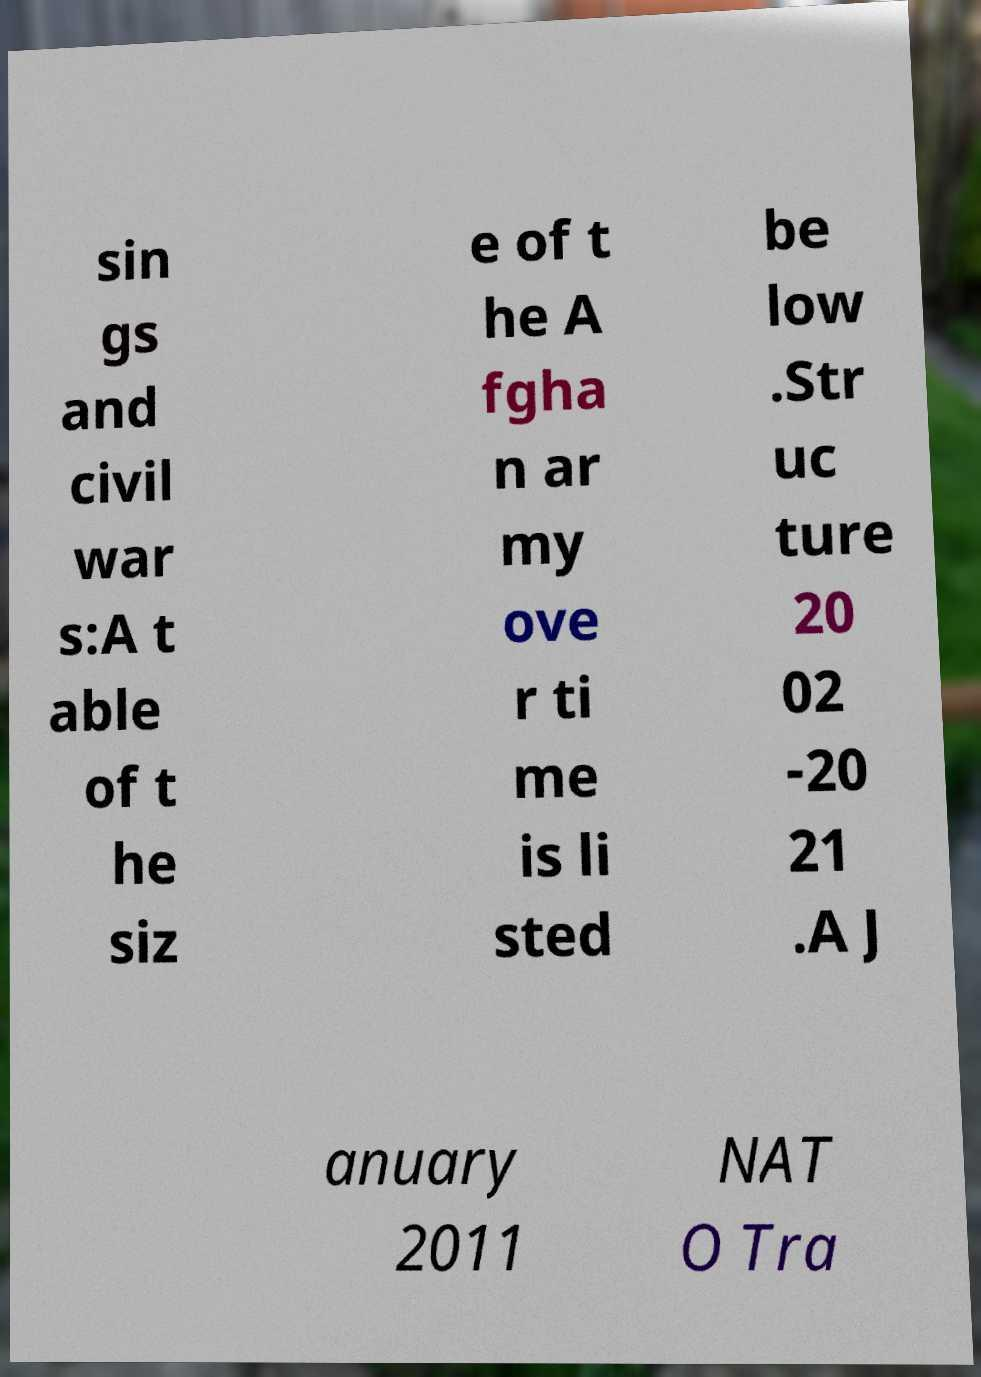What messages or text are displayed in this image? I need them in a readable, typed format. sin gs and civil war s:A t able of t he siz e of t he A fgha n ar my ove r ti me is li sted be low .Str uc ture 20 02 -20 21 .A J anuary 2011 NAT O Tra 